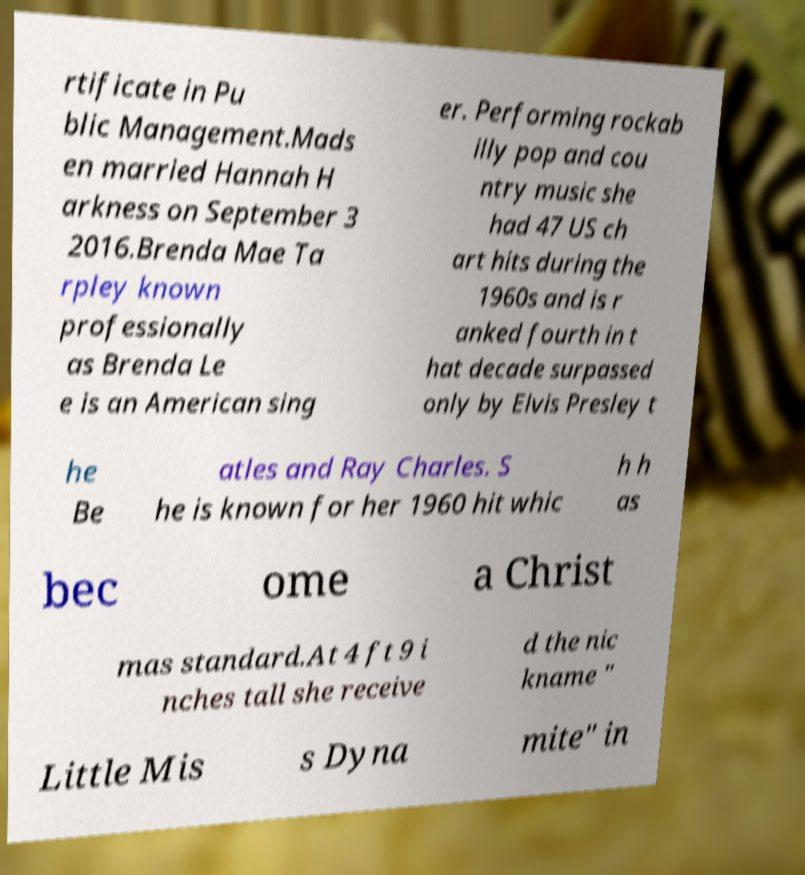For documentation purposes, I need the text within this image transcribed. Could you provide that? rtificate in Pu blic Management.Mads en married Hannah H arkness on September 3 2016.Brenda Mae Ta rpley known professionally as Brenda Le e is an American sing er. Performing rockab illy pop and cou ntry music she had 47 US ch art hits during the 1960s and is r anked fourth in t hat decade surpassed only by Elvis Presley t he Be atles and Ray Charles. S he is known for her 1960 hit whic h h as bec ome a Christ mas standard.At 4 ft 9 i nches tall she receive d the nic kname " Little Mis s Dyna mite" in 